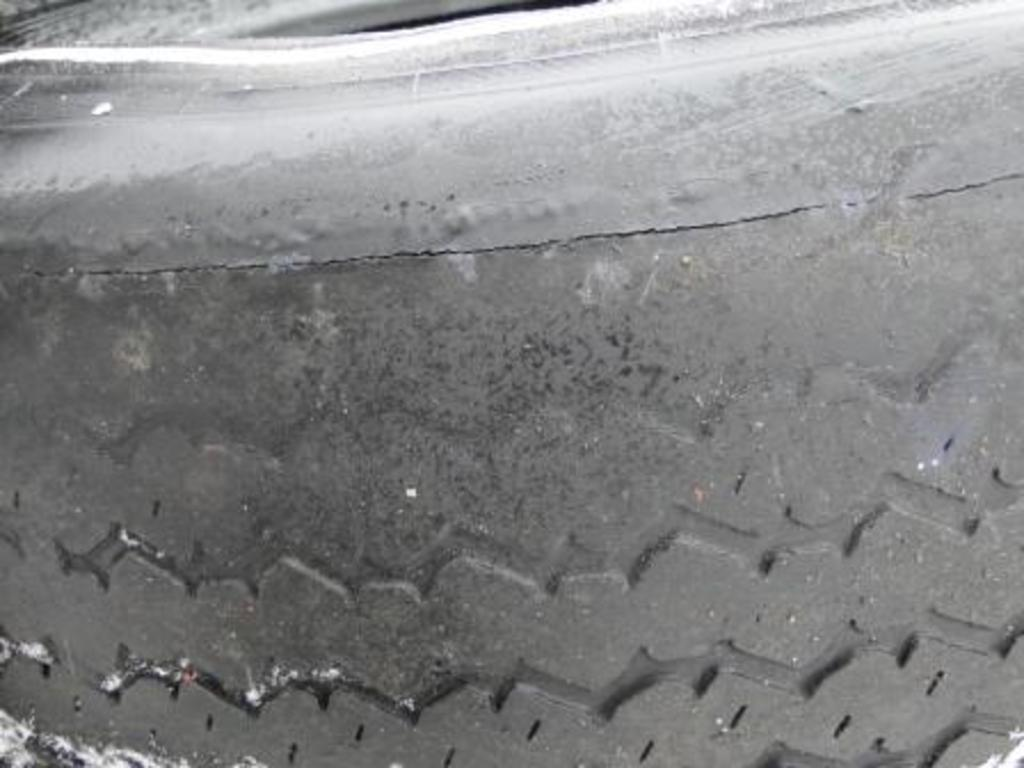What object is the main subject of the image? There is a tire in the image. What type of produce is hanging from the tire in the image? There is no produce present in the image; it only features a tire. 